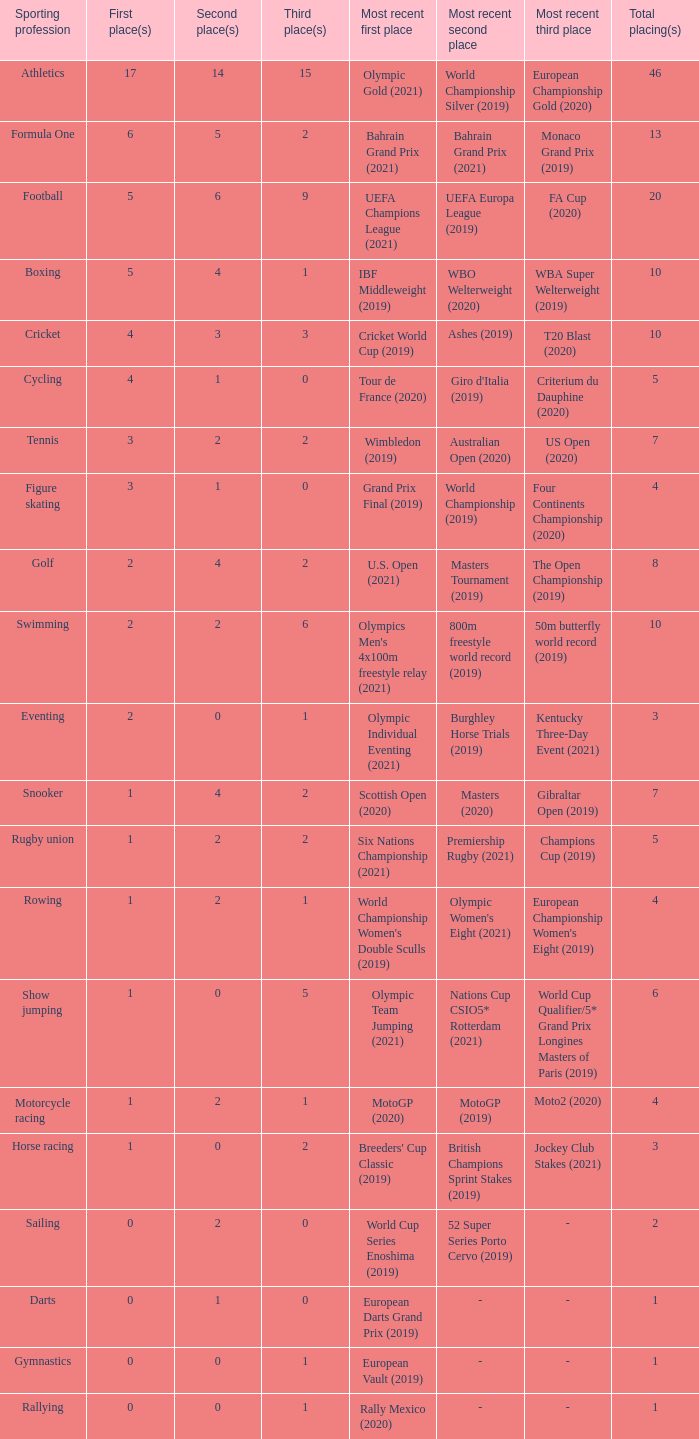What is the total number of 3rd place entries that have exactly 8 total placings? 1.0. 